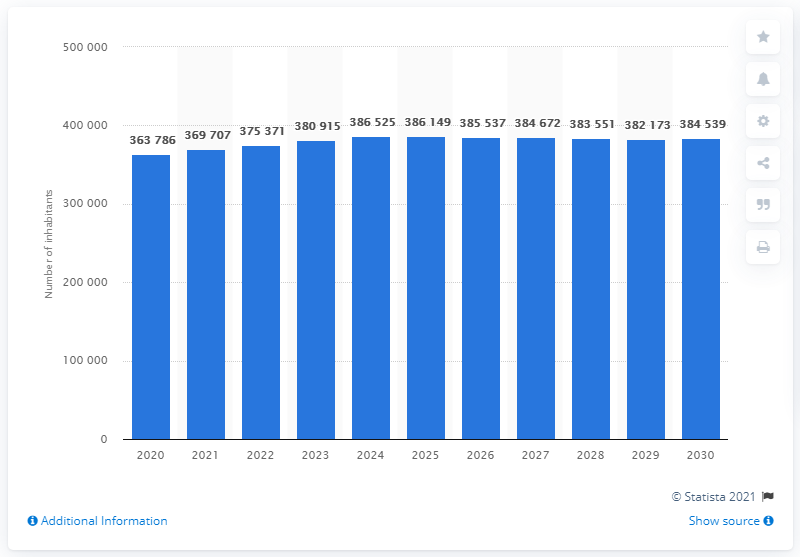What is the estimated population of Iceland by 2030?
 384539 